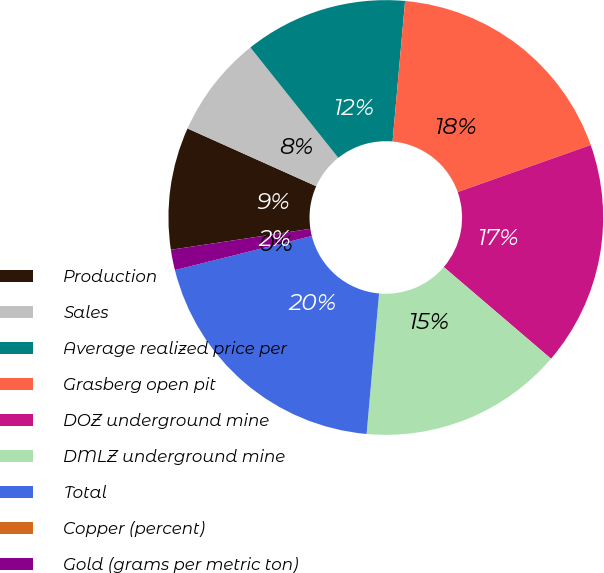Convert chart to OTSL. <chart><loc_0><loc_0><loc_500><loc_500><pie_chart><fcel>Production<fcel>Sales<fcel>Average realized price per<fcel>Grasberg open pit<fcel>DOZ underground mine<fcel>DMLZ underground mine<fcel>Total<fcel>Copper (percent)<fcel>Gold (grams per metric ton)<nl><fcel>9.09%<fcel>7.58%<fcel>12.12%<fcel>18.18%<fcel>16.67%<fcel>15.15%<fcel>19.7%<fcel>0.0%<fcel>1.52%<nl></chart> 